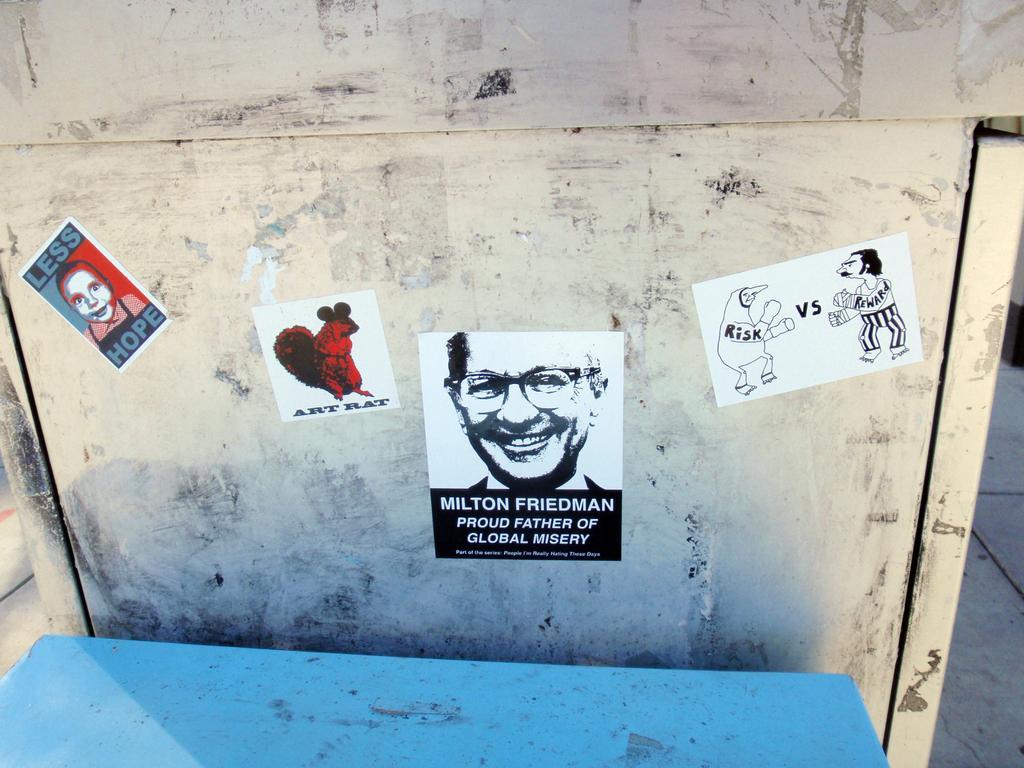In one or two sentences, can you explain what this image depicts? In the image there are some posters attached to a surface and in front of that there is some blue object. 